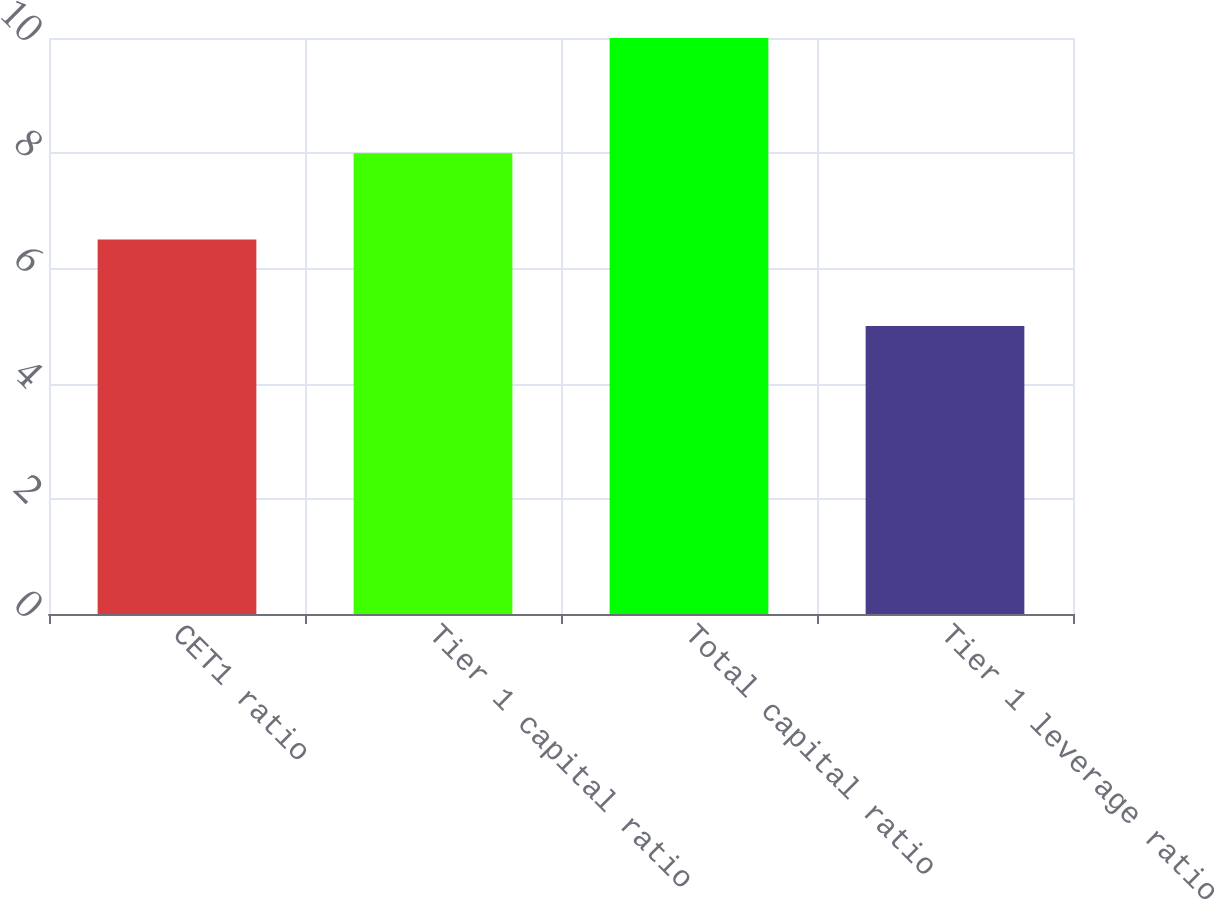Convert chart. <chart><loc_0><loc_0><loc_500><loc_500><bar_chart><fcel>CET1 ratio<fcel>Tier 1 capital ratio<fcel>Total capital ratio<fcel>Tier 1 leverage ratio<nl><fcel>6.5<fcel>8<fcel>10<fcel>5<nl></chart> 